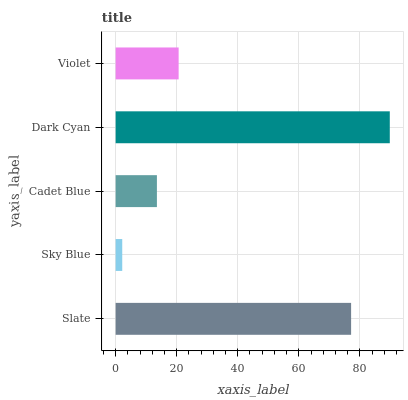Is Sky Blue the minimum?
Answer yes or no. Yes. Is Dark Cyan the maximum?
Answer yes or no. Yes. Is Cadet Blue the minimum?
Answer yes or no. No. Is Cadet Blue the maximum?
Answer yes or no. No. Is Cadet Blue greater than Sky Blue?
Answer yes or no. Yes. Is Sky Blue less than Cadet Blue?
Answer yes or no. Yes. Is Sky Blue greater than Cadet Blue?
Answer yes or no. No. Is Cadet Blue less than Sky Blue?
Answer yes or no. No. Is Violet the high median?
Answer yes or no. Yes. Is Violet the low median?
Answer yes or no. Yes. Is Cadet Blue the high median?
Answer yes or no. No. Is Slate the low median?
Answer yes or no. No. 